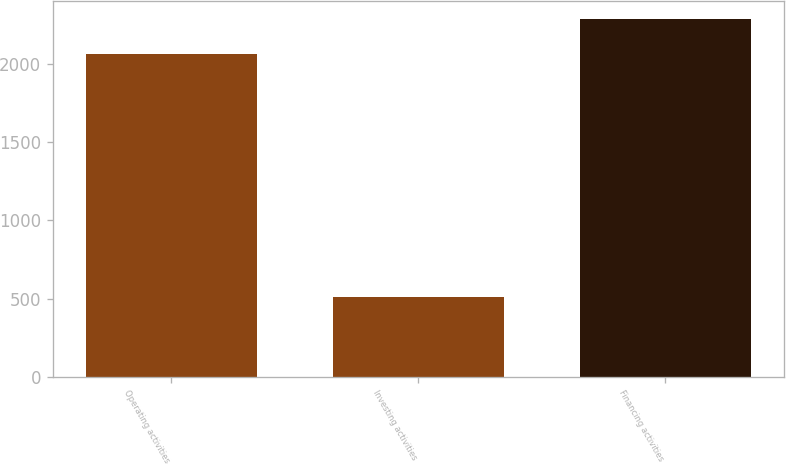Convert chart. <chart><loc_0><loc_0><loc_500><loc_500><bar_chart><fcel>Operating activities<fcel>Investing activities<fcel>Financing activities<nl><fcel>2064<fcel>513<fcel>2288<nl></chart> 